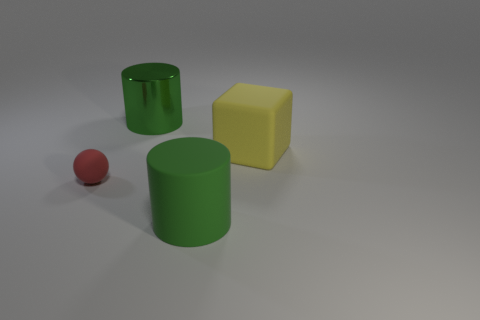Add 3 green matte objects. How many objects exist? 7 Subtract all balls. How many objects are left? 3 Subtract 1 cylinders. How many cylinders are left? 1 Subtract all big green rubber blocks. Subtract all rubber things. How many objects are left? 1 Add 4 small red rubber balls. How many small red rubber balls are left? 5 Add 2 blue cubes. How many blue cubes exist? 2 Subtract 0 yellow spheres. How many objects are left? 4 Subtract all yellow cylinders. Subtract all cyan cubes. How many cylinders are left? 2 